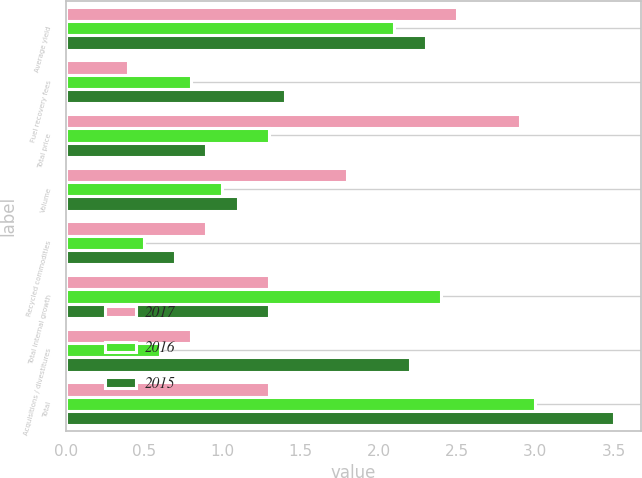Convert chart. <chart><loc_0><loc_0><loc_500><loc_500><stacked_bar_chart><ecel><fcel>Average yield<fcel>Fuel recovery fees<fcel>Total price<fcel>Volume<fcel>Recycled commodities<fcel>Total internal growth<fcel>Acquisitions / divestitures<fcel>Total<nl><fcel>2017<fcel>2.5<fcel>0.4<fcel>2.9<fcel>1.8<fcel>0.9<fcel>1.3<fcel>0.8<fcel>1.3<nl><fcel>2016<fcel>2.1<fcel>0.8<fcel>1.3<fcel>1<fcel>0.5<fcel>2.4<fcel>0.6<fcel>3<nl><fcel>2015<fcel>2.3<fcel>1.4<fcel>0.9<fcel>1.1<fcel>0.7<fcel>1.3<fcel>2.2<fcel>3.5<nl></chart> 